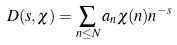<formula> <loc_0><loc_0><loc_500><loc_500>D ( s , \chi ) = \sum _ { n \leq N } a _ { n } \chi ( n ) n ^ { - s }</formula> 